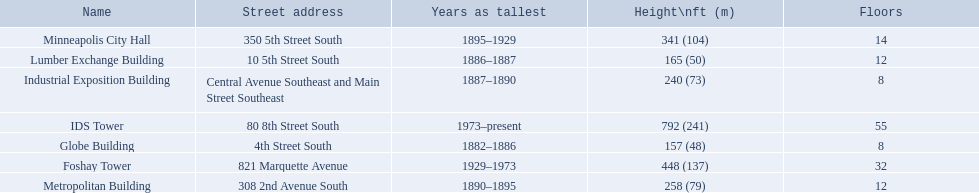What are the heights of the buildings? 157 (48), 165 (50), 240 (73), 258 (79), 341 (104), 448 (137), 792 (241). What building is 240 ft tall? Industrial Exposition Building. 